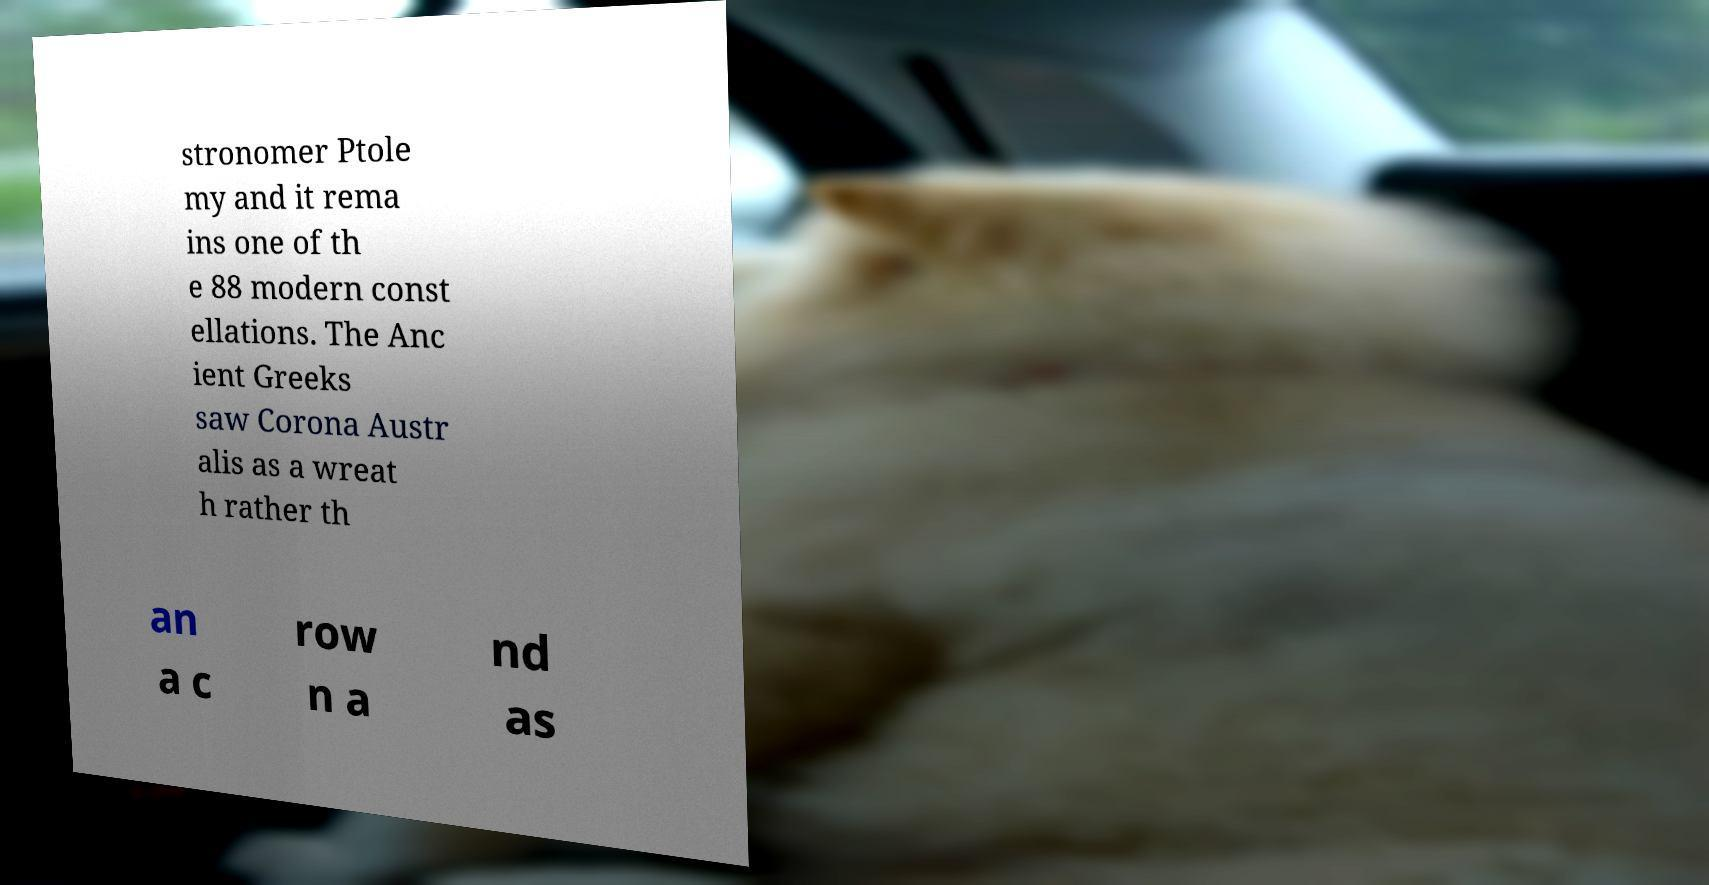Can you accurately transcribe the text from the provided image for me? stronomer Ptole my and it rema ins one of th e 88 modern const ellations. The Anc ient Greeks saw Corona Austr alis as a wreat h rather th an a c row n a nd as 